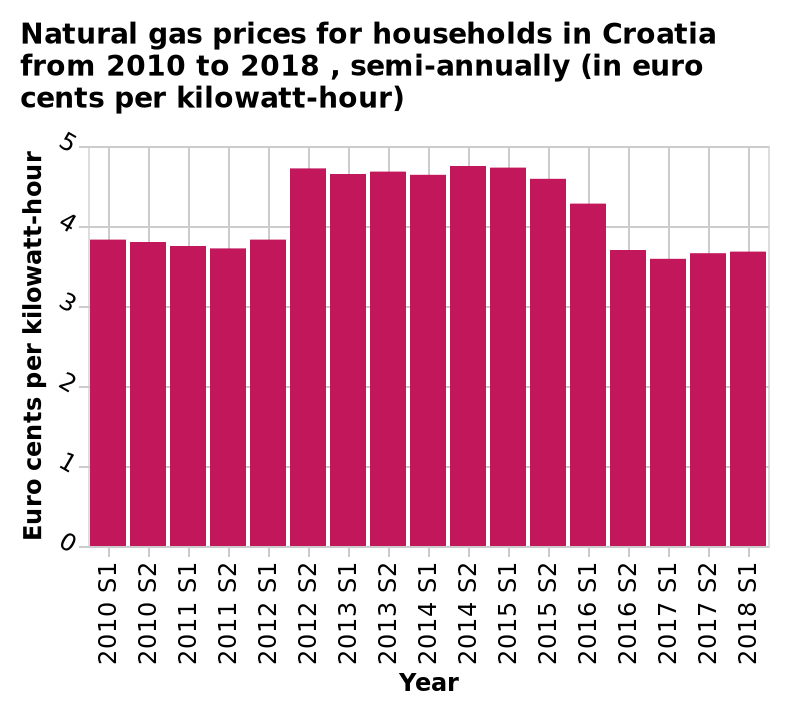<image>
How long did the highest cost per kilowatt-hour period last? The highest cost per kilowatt-hour period lasted from 2012 to 2016. When was the cost per kilowatt-hour under 4 euro cents?  The cost per kilowatt-hour was under 4 euro cents until S2 2012. What is the latest year represented on the x-axis? The latest year represented on the x-axis is 2018. Did the cost per kilowatt-hour decrease or increase from 2010 to 2012? The cost per kilowatt-hour decreased from 2010 to 2012. 